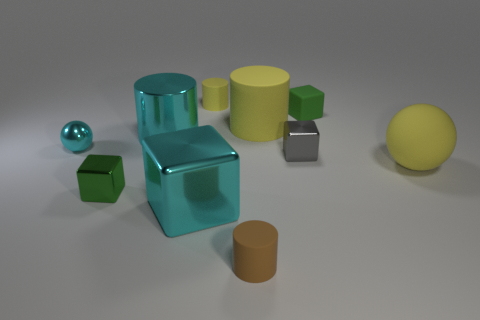Are there any tiny blocks right of the big cyan metallic thing that is in front of the cyan shiny ball?
Give a very brief answer. Yes. What color is the big thing that is the same shape as the tiny green rubber thing?
Keep it short and to the point. Cyan. Does the tiny rubber cylinder behind the large cyan cylinder have the same color as the big metal block?
Give a very brief answer. No. What number of things are small green rubber objects behind the large cyan cube or tiny objects?
Make the answer very short. 6. What material is the cyan thing in front of the sphere to the left of the big yellow rubber object that is right of the small gray thing?
Your response must be concise. Metal. Is the number of cyan metal blocks to the left of the matte cube greater than the number of tiny balls to the right of the big rubber cylinder?
Your response must be concise. Yes. How many cubes are tiny brown things or large yellow objects?
Provide a short and direct response. 0. There is a tiny green block in front of the small green cube on the right side of the small gray shiny block; what number of matte things are left of it?
Your answer should be compact. 0. There is a large cylinder that is the same color as the rubber sphere; what material is it?
Your response must be concise. Rubber. Are there more green objects than tiny cyan matte balls?
Your answer should be very brief. Yes. 